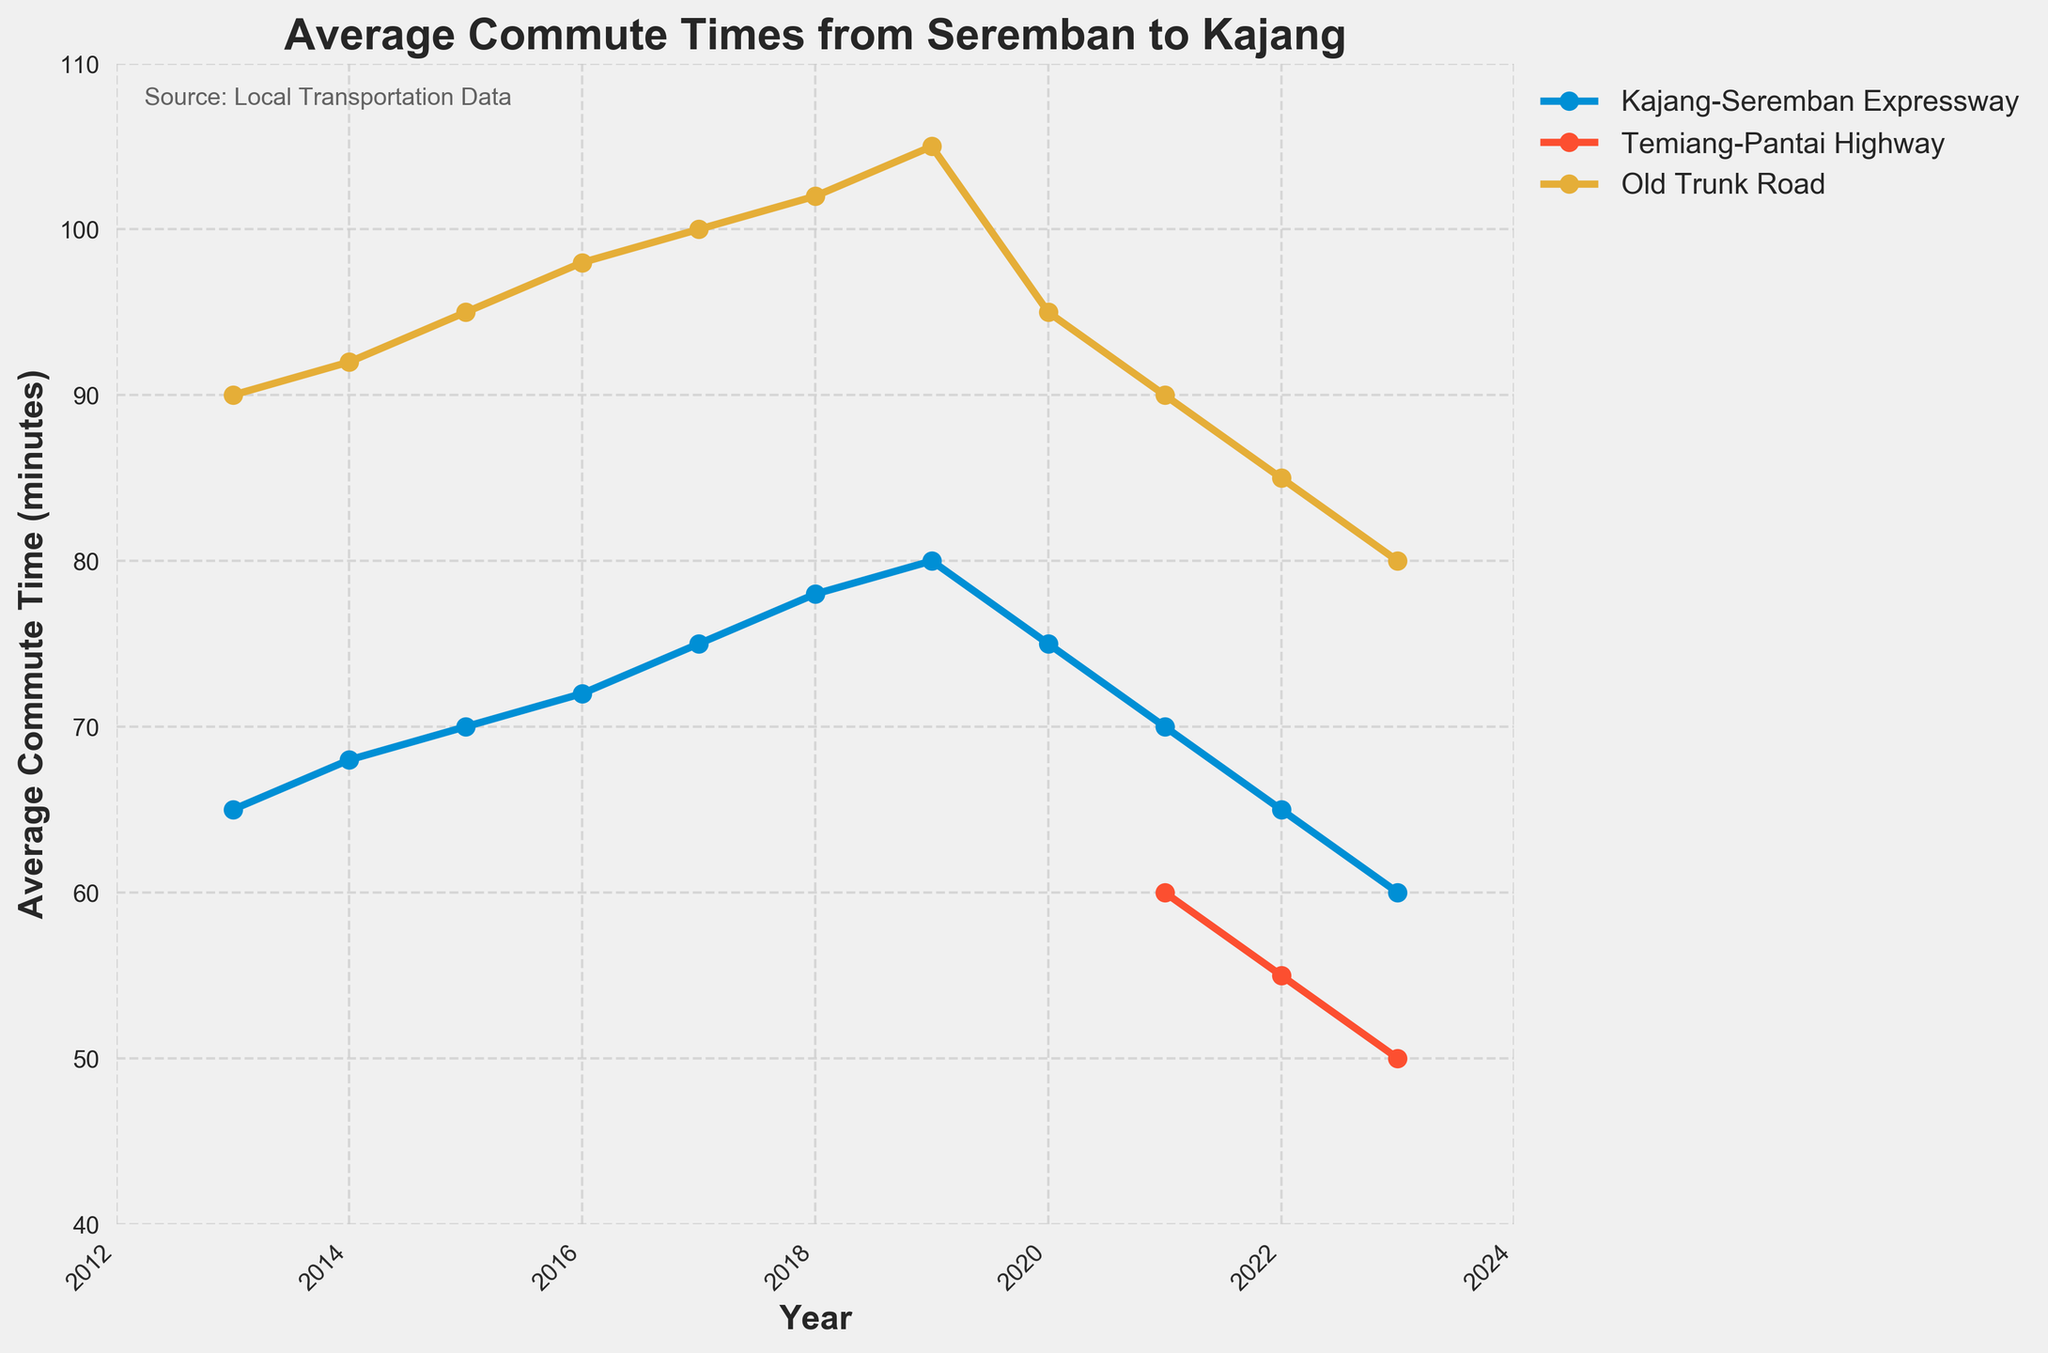What was the average commute time via the Kajang-Seremban Expressway in 2015? The year 2015 shows the average commute time for the Kajang-Seremban Expressway as plotted. By locating 2015 on the x-axis and moving up to the corresponding point on the graph, we identify the commute time.
Answer: 70 minutes How did the commute time via the Old Trunk Road change from 2013 to 2023? In 2013, the commute time for the Old Trunk Road was 90 minutes, and in 2023 it was 80 minutes. By subtracting the latter from the former, we find the change over the decade.
Answer: Decreased by 10 minutes Which route had the shortest commute time in 2023? In 2023, the line chart shows the commute times for all three routes. By comparing their values on the y-axis, we can see that the Temiang-Pantai Highway had the shortest time.
Answer: Temiang-Pantai Highway What was the trend of commute times via the Kajang-Seremban Expressway from 2013 to 2020? Observing the plotted line for the Kajang-Seremban Expressway from 2013 to 2020, the trend shows an initial increase in commute time each year until peaking in 2019 followed by a decrease in 2020.
Answer: Increased first, then decreased By how many minutes did the commute time via the Old Trunk Road change between 2020 and 2021? From the figure, the commute time via the Old Trunk Road was 95 minutes in 2020 and 90 minutes in 2021. Subtracting the latter from the former gives the change.
Answer: Decreased by 5 minutes Between which two consecutive years did the commute time via the Kajang-Seremban Expressway decrease the most? By examining the year-to-year changes in commute time for the Kajang-Seremban Expressway, the largest decrease is observed between 2019 and 2020 (from 80 minutes to 75 minutes, a drop of 5 minutes).
Answer: Between 2019 and 2020 How much difference is there between the average commute times of the Temiang-Pantai Highway and the Old Trunk Road in 2022? The commute time for the Temiang-Pantai Highway in 2022 was 55 minutes while for the Old Trunk Road it was 85 minutes. Subtracting the former from the latter gives the difference.
Answer: 30 minutes Which route showed a decline in average commute time from 2019 to 2020 and by how many minutes? Checking the plotted lines for each route, the Kajang-Seremban Expressway showed a decrease - from 80 minutes in 2019 to 75 minutes in 2020. The difference is 80 - 75.
Answer: Kajang-Seremban Expressway, by 5 minutes When did the Temiang-Pantai Highway first appear in the data, and what was the initial average commute time? Finding the first point on the line chart for the Temiang-Pantai Highway reveals its first data point in 2021, with the average commute time indicated by the line in that year.
Answer: 2021, 60 minutes How did the average commute time via the Temiang-Pantai Highway change from 2021 to 2023? The chart shows the commute time for the Temiang-Pantai Highway at 60 minutes in 2021 and decreasing to 50 minutes by 2023, indicating a reduction over these years.
Answer: Decreased by 10 minutes 